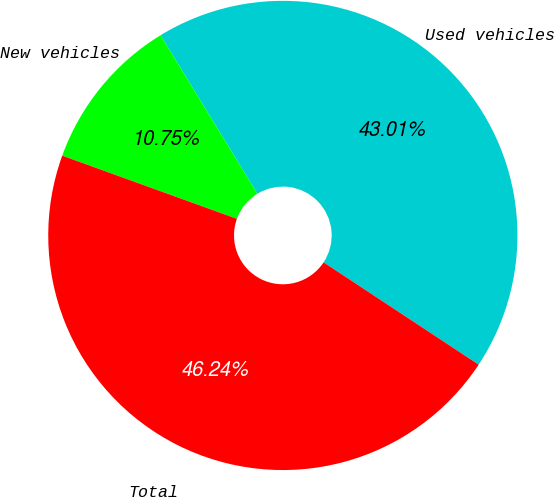Convert chart. <chart><loc_0><loc_0><loc_500><loc_500><pie_chart><fcel>Used vehicles<fcel>New vehicles<fcel>Total<nl><fcel>43.01%<fcel>10.75%<fcel>46.24%<nl></chart> 